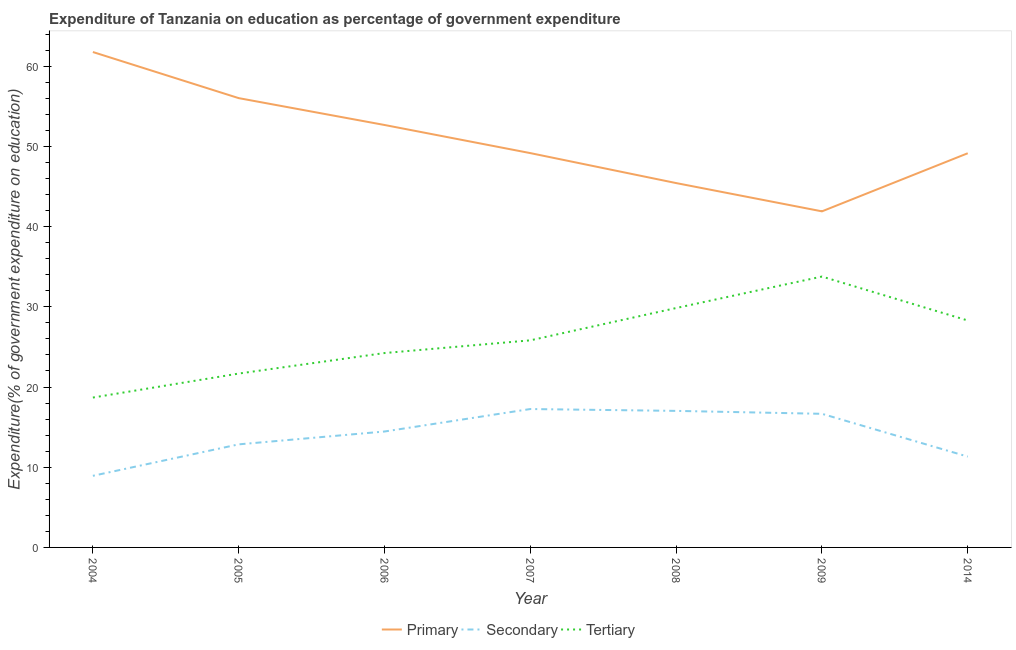How many different coloured lines are there?
Keep it short and to the point. 3. What is the expenditure on secondary education in 2004?
Offer a terse response. 8.93. Across all years, what is the maximum expenditure on secondary education?
Ensure brevity in your answer.  17.26. Across all years, what is the minimum expenditure on tertiary education?
Your response must be concise. 18.69. What is the total expenditure on tertiary education in the graph?
Offer a very short reply. 182.35. What is the difference between the expenditure on tertiary education in 2006 and that in 2007?
Your answer should be compact. -1.58. What is the difference between the expenditure on primary education in 2008 and the expenditure on secondary education in 2006?
Your answer should be compact. 30.98. What is the average expenditure on tertiary education per year?
Make the answer very short. 26.05. In the year 2006, what is the difference between the expenditure on primary education and expenditure on tertiary education?
Your answer should be very brief. 28.44. What is the ratio of the expenditure on primary education in 2006 to that in 2009?
Offer a very short reply. 1.26. Is the difference between the expenditure on secondary education in 2005 and 2007 greater than the difference between the expenditure on tertiary education in 2005 and 2007?
Your answer should be very brief. No. What is the difference between the highest and the second highest expenditure on secondary education?
Give a very brief answer. 0.23. What is the difference between the highest and the lowest expenditure on tertiary education?
Provide a short and direct response. 15.09. Does the expenditure on tertiary education monotonically increase over the years?
Your answer should be compact. No. How many years are there in the graph?
Make the answer very short. 7. Does the graph contain any zero values?
Make the answer very short. No. Where does the legend appear in the graph?
Keep it short and to the point. Bottom center. How many legend labels are there?
Provide a short and direct response. 3. What is the title of the graph?
Keep it short and to the point. Expenditure of Tanzania on education as percentage of government expenditure. What is the label or title of the Y-axis?
Keep it short and to the point. Expenditure(% of government expenditure on education). What is the Expenditure(% of government expenditure on education) of Primary in 2004?
Offer a very short reply. 61.77. What is the Expenditure(% of government expenditure on education) of Secondary in 2004?
Give a very brief answer. 8.93. What is the Expenditure(% of government expenditure on education) in Tertiary in 2004?
Offer a very short reply. 18.69. What is the Expenditure(% of government expenditure on education) of Primary in 2005?
Your answer should be very brief. 56.02. What is the Expenditure(% of government expenditure on education) in Secondary in 2005?
Your answer should be very brief. 12.85. What is the Expenditure(% of government expenditure on education) in Tertiary in 2005?
Offer a terse response. 21.68. What is the Expenditure(% of government expenditure on education) in Primary in 2006?
Your answer should be compact. 52.68. What is the Expenditure(% of government expenditure on education) of Secondary in 2006?
Provide a succinct answer. 14.45. What is the Expenditure(% of government expenditure on education) in Tertiary in 2006?
Your answer should be compact. 24.24. What is the Expenditure(% of government expenditure on education) in Primary in 2007?
Provide a succinct answer. 49.17. What is the Expenditure(% of government expenditure on education) of Secondary in 2007?
Your response must be concise. 17.26. What is the Expenditure(% of government expenditure on education) in Tertiary in 2007?
Make the answer very short. 25.82. What is the Expenditure(% of government expenditure on education) of Primary in 2008?
Make the answer very short. 45.43. What is the Expenditure(% of government expenditure on education) in Secondary in 2008?
Offer a very short reply. 17.03. What is the Expenditure(% of government expenditure on education) of Tertiary in 2008?
Keep it short and to the point. 29.85. What is the Expenditure(% of government expenditure on education) of Primary in 2009?
Provide a short and direct response. 41.91. What is the Expenditure(% of government expenditure on education) in Secondary in 2009?
Provide a short and direct response. 16.66. What is the Expenditure(% of government expenditure on education) in Tertiary in 2009?
Your answer should be very brief. 33.78. What is the Expenditure(% of government expenditure on education) in Primary in 2014?
Your answer should be compact. 49.15. What is the Expenditure(% of government expenditure on education) in Secondary in 2014?
Keep it short and to the point. 11.32. What is the Expenditure(% of government expenditure on education) of Tertiary in 2014?
Offer a very short reply. 28.3. Across all years, what is the maximum Expenditure(% of government expenditure on education) in Primary?
Provide a succinct answer. 61.77. Across all years, what is the maximum Expenditure(% of government expenditure on education) in Secondary?
Provide a short and direct response. 17.26. Across all years, what is the maximum Expenditure(% of government expenditure on education) of Tertiary?
Make the answer very short. 33.78. Across all years, what is the minimum Expenditure(% of government expenditure on education) of Primary?
Provide a succinct answer. 41.91. Across all years, what is the minimum Expenditure(% of government expenditure on education) in Secondary?
Your answer should be very brief. 8.93. Across all years, what is the minimum Expenditure(% of government expenditure on education) of Tertiary?
Offer a very short reply. 18.69. What is the total Expenditure(% of government expenditure on education) of Primary in the graph?
Offer a very short reply. 356.13. What is the total Expenditure(% of government expenditure on education) in Secondary in the graph?
Your answer should be very brief. 98.5. What is the total Expenditure(% of government expenditure on education) in Tertiary in the graph?
Offer a terse response. 182.35. What is the difference between the Expenditure(% of government expenditure on education) of Primary in 2004 and that in 2005?
Offer a very short reply. 5.75. What is the difference between the Expenditure(% of government expenditure on education) in Secondary in 2004 and that in 2005?
Your answer should be very brief. -3.92. What is the difference between the Expenditure(% of government expenditure on education) of Tertiary in 2004 and that in 2005?
Offer a terse response. -2.99. What is the difference between the Expenditure(% of government expenditure on education) of Primary in 2004 and that in 2006?
Provide a succinct answer. 9.1. What is the difference between the Expenditure(% of government expenditure on education) of Secondary in 2004 and that in 2006?
Give a very brief answer. -5.52. What is the difference between the Expenditure(% of government expenditure on education) of Tertiary in 2004 and that in 2006?
Keep it short and to the point. -5.55. What is the difference between the Expenditure(% of government expenditure on education) of Primary in 2004 and that in 2007?
Your answer should be very brief. 12.61. What is the difference between the Expenditure(% of government expenditure on education) in Secondary in 2004 and that in 2007?
Offer a very short reply. -8.33. What is the difference between the Expenditure(% of government expenditure on education) of Tertiary in 2004 and that in 2007?
Offer a very short reply. -7.13. What is the difference between the Expenditure(% of government expenditure on education) of Primary in 2004 and that in 2008?
Provide a succinct answer. 16.34. What is the difference between the Expenditure(% of government expenditure on education) of Secondary in 2004 and that in 2008?
Keep it short and to the point. -8.1. What is the difference between the Expenditure(% of government expenditure on education) in Tertiary in 2004 and that in 2008?
Provide a short and direct response. -11.16. What is the difference between the Expenditure(% of government expenditure on education) of Primary in 2004 and that in 2009?
Offer a terse response. 19.87. What is the difference between the Expenditure(% of government expenditure on education) in Secondary in 2004 and that in 2009?
Provide a short and direct response. -7.73. What is the difference between the Expenditure(% of government expenditure on education) of Tertiary in 2004 and that in 2009?
Your answer should be compact. -15.09. What is the difference between the Expenditure(% of government expenditure on education) of Primary in 2004 and that in 2014?
Your answer should be very brief. 12.62. What is the difference between the Expenditure(% of government expenditure on education) in Secondary in 2004 and that in 2014?
Keep it short and to the point. -2.39. What is the difference between the Expenditure(% of government expenditure on education) of Tertiary in 2004 and that in 2014?
Make the answer very short. -9.61. What is the difference between the Expenditure(% of government expenditure on education) in Primary in 2005 and that in 2006?
Your response must be concise. 3.35. What is the difference between the Expenditure(% of government expenditure on education) of Secondary in 2005 and that in 2006?
Your answer should be very brief. -1.6. What is the difference between the Expenditure(% of government expenditure on education) of Tertiary in 2005 and that in 2006?
Offer a terse response. -2.56. What is the difference between the Expenditure(% of government expenditure on education) in Primary in 2005 and that in 2007?
Ensure brevity in your answer.  6.85. What is the difference between the Expenditure(% of government expenditure on education) of Secondary in 2005 and that in 2007?
Offer a very short reply. -4.41. What is the difference between the Expenditure(% of government expenditure on education) of Tertiary in 2005 and that in 2007?
Give a very brief answer. -4.14. What is the difference between the Expenditure(% of government expenditure on education) in Primary in 2005 and that in 2008?
Your answer should be compact. 10.59. What is the difference between the Expenditure(% of government expenditure on education) in Secondary in 2005 and that in 2008?
Your answer should be compact. -4.17. What is the difference between the Expenditure(% of government expenditure on education) of Tertiary in 2005 and that in 2008?
Give a very brief answer. -8.17. What is the difference between the Expenditure(% of government expenditure on education) of Primary in 2005 and that in 2009?
Provide a succinct answer. 14.12. What is the difference between the Expenditure(% of government expenditure on education) of Secondary in 2005 and that in 2009?
Offer a very short reply. -3.81. What is the difference between the Expenditure(% of government expenditure on education) in Tertiary in 2005 and that in 2009?
Offer a terse response. -12.1. What is the difference between the Expenditure(% of government expenditure on education) in Primary in 2005 and that in 2014?
Make the answer very short. 6.87. What is the difference between the Expenditure(% of government expenditure on education) in Secondary in 2005 and that in 2014?
Offer a very short reply. 1.53. What is the difference between the Expenditure(% of government expenditure on education) of Tertiary in 2005 and that in 2014?
Your answer should be compact. -6.62. What is the difference between the Expenditure(% of government expenditure on education) in Primary in 2006 and that in 2007?
Keep it short and to the point. 3.51. What is the difference between the Expenditure(% of government expenditure on education) in Secondary in 2006 and that in 2007?
Offer a very short reply. -2.8. What is the difference between the Expenditure(% of government expenditure on education) of Tertiary in 2006 and that in 2007?
Your response must be concise. -1.58. What is the difference between the Expenditure(% of government expenditure on education) in Primary in 2006 and that in 2008?
Keep it short and to the point. 7.24. What is the difference between the Expenditure(% of government expenditure on education) of Secondary in 2006 and that in 2008?
Ensure brevity in your answer.  -2.57. What is the difference between the Expenditure(% of government expenditure on education) in Tertiary in 2006 and that in 2008?
Offer a terse response. -5.61. What is the difference between the Expenditure(% of government expenditure on education) of Primary in 2006 and that in 2009?
Make the answer very short. 10.77. What is the difference between the Expenditure(% of government expenditure on education) of Secondary in 2006 and that in 2009?
Your response must be concise. -2.21. What is the difference between the Expenditure(% of government expenditure on education) of Tertiary in 2006 and that in 2009?
Provide a succinct answer. -9.54. What is the difference between the Expenditure(% of government expenditure on education) of Primary in 2006 and that in 2014?
Your answer should be very brief. 3.53. What is the difference between the Expenditure(% of government expenditure on education) of Secondary in 2006 and that in 2014?
Provide a short and direct response. 3.13. What is the difference between the Expenditure(% of government expenditure on education) of Tertiary in 2006 and that in 2014?
Offer a very short reply. -4.06. What is the difference between the Expenditure(% of government expenditure on education) in Primary in 2007 and that in 2008?
Your answer should be compact. 3.74. What is the difference between the Expenditure(% of government expenditure on education) in Secondary in 2007 and that in 2008?
Ensure brevity in your answer.  0.23. What is the difference between the Expenditure(% of government expenditure on education) of Tertiary in 2007 and that in 2008?
Make the answer very short. -4.03. What is the difference between the Expenditure(% of government expenditure on education) of Primary in 2007 and that in 2009?
Your answer should be compact. 7.26. What is the difference between the Expenditure(% of government expenditure on education) of Secondary in 2007 and that in 2009?
Provide a short and direct response. 0.6. What is the difference between the Expenditure(% of government expenditure on education) in Tertiary in 2007 and that in 2009?
Provide a succinct answer. -7.95. What is the difference between the Expenditure(% of government expenditure on education) of Primary in 2007 and that in 2014?
Offer a terse response. 0.02. What is the difference between the Expenditure(% of government expenditure on education) in Secondary in 2007 and that in 2014?
Provide a succinct answer. 5.93. What is the difference between the Expenditure(% of government expenditure on education) of Tertiary in 2007 and that in 2014?
Provide a short and direct response. -2.47. What is the difference between the Expenditure(% of government expenditure on education) of Primary in 2008 and that in 2009?
Keep it short and to the point. 3.53. What is the difference between the Expenditure(% of government expenditure on education) in Secondary in 2008 and that in 2009?
Provide a succinct answer. 0.37. What is the difference between the Expenditure(% of government expenditure on education) in Tertiary in 2008 and that in 2009?
Provide a succinct answer. -3.93. What is the difference between the Expenditure(% of government expenditure on education) of Primary in 2008 and that in 2014?
Ensure brevity in your answer.  -3.72. What is the difference between the Expenditure(% of government expenditure on education) in Secondary in 2008 and that in 2014?
Provide a succinct answer. 5.7. What is the difference between the Expenditure(% of government expenditure on education) in Tertiary in 2008 and that in 2014?
Provide a short and direct response. 1.55. What is the difference between the Expenditure(% of government expenditure on education) of Primary in 2009 and that in 2014?
Keep it short and to the point. -7.24. What is the difference between the Expenditure(% of government expenditure on education) of Secondary in 2009 and that in 2014?
Offer a very short reply. 5.34. What is the difference between the Expenditure(% of government expenditure on education) in Tertiary in 2009 and that in 2014?
Your response must be concise. 5.48. What is the difference between the Expenditure(% of government expenditure on education) in Primary in 2004 and the Expenditure(% of government expenditure on education) in Secondary in 2005?
Give a very brief answer. 48.92. What is the difference between the Expenditure(% of government expenditure on education) of Primary in 2004 and the Expenditure(% of government expenditure on education) of Tertiary in 2005?
Your answer should be compact. 40.09. What is the difference between the Expenditure(% of government expenditure on education) of Secondary in 2004 and the Expenditure(% of government expenditure on education) of Tertiary in 2005?
Provide a succinct answer. -12.75. What is the difference between the Expenditure(% of government expenditure on education) of Primary in 2004 and the Expenditure(% of government expenditure on education) of Secondary in 2006?
Make the answer very short. 47.32. What is the difference between the Expenditure(% of government expenditure on education) in Primary in 2004 and the Expenditure(% of government expenditure on education) in Tertiary in 2006?
Ensure brevity in your answer.  37.54. What is the difference between the Expenditure(% of government expenditure on education) of Secondary in 2004 and the Expenditure(% of government expenditure on education) of Tertiary in 2006?
Your answer should be compact. -15.31. What is the difference between the Expenditure(% of government expenditure on education) in Primary in 2004 and the Expenditure(% of government expenditure on education) in Secondary in 2007?
Offer a very short reply. 44.52. What is the difference between the Expenditure(% of government expenditure on education) of Primary in 2004 and the Expenditure(% of government expenditure on education) of Tertiary in 2007?
Offer a terse response. 35.95. What is the difference between the Expenditure(% of government expenditure on education) in Secondary in 2004 and the Expenditure(% of government expenditure on education) in Tertiary in 2007?
Make the answer very short. -16.89. What is the difference between the Expenditure(% of government expenditure on education) of Primary in 2004 and the Expenditure(% of government expenditure on education) of Secondary in 2008?
Your answer should be very brief. 44.75. What is the difference between the Expenditure(% of government expenditure on education) of Primary in 2004 and the Expenditure(% of government expenditure on education) of Tertiary in 2008?
Make the answer very short. 31.92. What is the difference between the Expenditure(% of government expenditure on education) in Secondary in 2004 and the Expenditure(% of government expenditure on education) in Tertiary in 2008?
Ensure brevity in your answer.  -20.92. What is the difference between the Expenditure(% of government expenditure on education) of Primary in 2004 and the Expenditure(% of government expenditure on education) of Secondary in 2009?
Your answer should be compact. 45.11. What is the difference between the Expenditure(% of government expenditure on education) in Primary in 2004 and the Expenditure(% of government expenditure on education) in Tertiary in 2009?
Provide a short and direct response. 28. What is the difference between the Expenditure(% of government expenditure on education) of Secondary in 2004 and the Expenditure(% of government expenditure on education) of Tertiary in 2009?
Ensure brevity in your answer.  -24.85. What is the difference between the Expenditure(% of government expenditure on education) of Primary in 2004 and the Expenditure(% of government expenditure on education) of Secondary in 2014?
Offer a terse response. 50.45. What is the difference between the Expenditure(% of government expenditure on education) in Primary in 2004 and the Expenditure(% of government expenditure on education) in Tertiary in 2014?
Your response must be concise. 33.48. What is the difference between the Expenditure(% of government expenditure on education) of Secondary in 2004 and the Expenditure(% of government expenditure on education) of Tertiary in 2014?
Offer a very short reply. -19.37. What is the difference between the Expenditure(% of government expenditure on education) in Primary in 2005 and the Expenditure(% of government expenditure on education) in Secondary in 2006?
Provide a succinct answer. 41.57. What is the difference between the Expenditure(% of government expenditure on education) in Primary in 2005 and the Expenditure(% of government expenditure on education) in Tertiary in 2006?
Offer a terse response. 31.79. What is the difference between the Expenditure(% of government expenditure on education) of Secondary in 2005 and the Expenditure(% of government expenditure on education) of Tertiary in 2006?
Give a very brief answer. -11.39. What is the difference between the Expenditure(% of government expenditure on education) of Primary in 2005 and the Expenditure(% of government expenditure on education) of Secondary in 2007?
Provide a succinct answer. 38.77. What is the difference between the Expenditure(% of government expenditure on education) of Primary in 2005 and the Expenditure(% of government expenditure on education) of Tertiary in 2007?
Provide a succinct answer. 30.2. What is the difference between the Expenditure(% of government expenditure on education) of Secondary in 2005 and the Expenditure(% of government expenditure on education) of Tertiary in 2007?
Your answer should be compact. -12.97. What is the difference between the Expenditure(% of government expenditure on education) of Primary in 2005 and the Expenditure(% of government expenditure on education) of Secondary in 2008?
Make the answer very short. 39. What is the difference between the Expenditure(% of government expenditure on education) in Primary in 2005 and the Expenditure(% of government expenditure on education) in Tertiary in 2008?
Your response must be concise. 26.17. What is the difference between the Expenditure(% of government expenditure on education) of Secondary in 2005 and the Expenditure(% of government expenditure on education) of Tertiary in 2008?
Your answer should be compact. -17. What is the difference between the Expenditure(% of government expenditure on education) in Primary in 2005 and the Expenditure(% of government expenditure on education) in Secondary in 2009?
Provide a short and direct response. 39.36. What is the difference between the Expenditure(% of government expenditure on education) of Primary in 2005 and the Expenditure(% of government expenditure on education) of Tertiary in 2009?
Your answer should be very brief. 22.25. What is the difference between the Expenditure(% of government expenditure on education) in Secondary in 2005 and the Expenditure(% of government expenditure on education) in Tertiary in 2009?
Give a very brief answer. -20.92. What is the difference between the Expenditure(% of government expenditure on education) in Primary in 2005 and the Expenditure(% of government expenditure on education) in Secondary in 2014?
Your answer should be very brief. 44.7. What is the difference between the Expenditure(% of government expenditure on education) in Primary in 2005 and the Expenditure(% of government expenditure on education) in Tertiary in 2014?
Your response must be concise. 27.73. What is the difference between the Expenditure(% of government expenditure on education) in Secondary in 2005 and the Expenditure(% of government expenditure on education) in Tertiary in 2014?
Make the answer very short. -15.45. What is the difference between the Expenditure(% of government expenditure on education) in Primary in 2006 and the Expenditure(% of government expenditure on education) in Secondary in 2007?
Your response must be concise. 35.42. What is the difference between the Expenditure(% of government expenditure on education) of Primary in 2006 and the Expenditure(% of government expenditure on education) of Tertiary in 2007?
Your answer should be very brief. 26.85. What is the difference between the Expenditure(% of government expenditure on education) of Secondary in 2006 and the Expenditure(% of government expenditure on education) of Tertiary in 2007?
Offer a terse response. -11.37. What is the difference between the Expenditure(% of government expenditure on education) of Primary in 2006 and the Expenditure(% of government expenditure on education) of Secondary in 2008?
Make the answer very short. 35.65. What is the difference between the Expenditure(% of government expenditure on education) in Primary in 2006 and the Expenditure(% of government expenditure on education) in Tertiary in 2008?
Provide a short and direct response. 22.83. What is the difference between the Expenditure(% of government expenditure on education) of Secondary in 2006 and the Expenditure(% of government expenditure on education) of Tertiary in 2008?
Provide a succinct answer. -15.4. What is the difference between the Expenditure(% of government expenditure on education) of Primary in 2006 and the Expenditure(% of government expenditure on education) of Secondary in 2009?
Ensure brevity in your answer.  36.02. What is the difference between the Expenditure(% of government expenditure on education) of Primary in 2006 and the Expenditure(% of government expenditure on education) of Tertiary in 2009?
Ensure brevity in your answer.  18.9. What is the difference between the Expenditure(% of government expenditure on education) in Secondary in 2006 and the Expenditure(% of government expenditure on education) in Tertiary in 2009?
Your response must be concise. -19.32. What is the difference between the Expenditure(% of government expenditure on education) in Primary in 2006 and the Expenditure(% of government expenditure on education) in Secondary in 2014?
Offer a terse response. 41.35. What is the difference between the Expenditure(% of government expenditure on education) in Primary in 2006 and the Expenditure(% of government expenditure on education) in Tertiary in 2014?
Provide a succinct answer. 24.38. What is the difference between the Expenditure(% of government expenditure on education) in Secondary in 2006 and the Expenditure(% of government expenditure on education) in Tertiary in 2014?
Ensure brevity in your answer.  -13.84. What is the difference between the Expenditure(% of government expenditure on education) of Primary in 2007 and the Expenditure(% of government expenditure on education) of Secondary in 2008?
Offer a very short reply. 32.14. What is the difference between the Expenditure(% of government expenditure on education) of Primary in 2007 and the Expenditure(% of government expenditure on education) of Tertiary in 2008?
Make the answer very short. 19.32. What is the difference between the Expenditure(% of government expenditure on education) of Secondary in 2007 and the Expenditure(% of government expenditure on education) of Tertiary in 2008?
Keep it short and to the point. -12.59. What is the difference between the Expenditure(% of government expenditure on education) in Primary in 2007 and the Expenditure(% of government expenditure on education) in Secondary in 2009?
Your answer should be very brief. 32.51. What is the difference between the Expenditure(% of government expenditure on education) in Primary in 2007 and the Expenditure(% of government expenditure on education) in Tertiary in 2009?
Provide a short and direct response. 15.39. What is the difference between the Expenditure(% of government expenditure on education) of Secondary in 2007 and the Expenditure(% of government expenditure on education) of Tertiary in 2009?
Offer a terse response. -16.52. What is the difference between the Expenditure(% of government expenditure on education) in Primary in 2007 and the Expenditure(% of government expenditure on education) in Secondary in 2014?
Offer a terse response. 37.84. What is the difference between the Expenditure(% of government expenditure on education) in Primary in 2007 and the Expenditure(% of government expenditure on education) in Tertiary in 2014?
Ensure brevity in your answer.  20.87. What is the difference between the Expenditure(% of government expenditure on education) in Secondary in 2007 and the Expenditure(% of government expenditure on education) in Tertiary in 2014?
Provide a short and direct response. -11.04. What is the difference between the Expenditure(% of government expenditure on education) in Primary in 2008 and the Expenditure(% of government expenditure on education) in Secondary in 2009?
Your answer should be compact. 28.77. What is the difference between the Expenditure(% of government expenditure on education) in Primary in 2008 and the Expenditure(% of government expenditure on education) in Tertiary in 2009?
Offer a terse response. 11.66. What is the difference between the Expenditure(% of government expenditure on education) in Secondary in 2008 and the Expenditure(% of government expenditure on education) in Tertiary in 2009?
Provide a succinct answer. -16.75. What is the difference between the Expenditure(% of government expenditure on education) of Primary in 2008 and the Expenditure(% of government expenditure on education) of Secondary in 2014?
Give a very brief answer. 34.11. What is the difference between the Expenditure(% of government expenditure on education) in Primary in 2008 and the Expenditure(% of government expenditure on education) in Tertiary in 2014?
Keep it short and to the point. 17.14. What is the difference between the Expenditure(% of government expenditure on education) in Secondary in 2008 and the Expenditure(% of government expenditure on education) in Tertiary in 2014?
Provide a short and direct response. -11.27. What is the difference between the Expenditure(% of government expenditure on education) of Primary in 2009 and the Expenditure(% of government expenditure on education) of Secondary in 2014?
Your answer should be very brief. 30.58. What is the difference between the Expenditure(% of government expenditure on education) in Primary in 2009 and the Expenditure(% of government expenditure on education) in Tertiary in 2014?
Make the answer very short. 13.61. What is the difference between the Expenditure(% of government expenditure on education) in Secondary in 2009 and the Expenditure(% of government expenditure on education) in Tertiary in 2014?
Provide a short and direct response. -11.64. What is the average Expenditure(% of government expenditure on education) of Primary per year?
Your answer should be very brief. 50.88. What is the average Expenditure(% of government expenditure on education) of Secondary per year?
Keep it short and to the point. 14.07. What is the average Expenditure(% of government expenditure on education) in Tertiary per year?
Provide a succinct answer. 26.05. In the year 2004, what is the difference between the Expenditure(% of government expenditure on education) of Primary and Expenditure(% of government expenditure on education) of Secondary?
Offer a terse response. 52.84. In the year 2004, what is the difference between the Expenditure(% of government expenditure on education) in Primary and Expenditure(% of government expenditure on education) in Tertiary?
Keep it short and to the point. 43.09. In the year 2004, what is the difference between the Expenditure(% of government expenditure on education) in Secondary and Expenditure(% of government expenditure on education) in Tertiary?
Your answer should be very brief. -9.76. In the year 2005, what is the difference between the Expenditure(% of government expenditure on education) in Primary and Expenditure(% of government expenditure on education) in Secondary?
Provide a succinct answer. 43.17. In the year 2005, what is the difference between the Expenditure(% of government expenditure on education) in Primary and Expenditure(% of government expenditure on education) in Tertiary?
Provide a succinct answer. 34.34. In the year 2005, what is the difference between the Expenditure(% of government expenditure on education) of Secondary and Expenditure(% of government expenditure on education) of Tertiary?
Make the answer very short. -8.83. In the year 2006, what is the difference between the Expenditure(% of government expenditure on education) in Primary and Expenditure(% of government expenditure on education) in Secondary?
Your answer should be very brief. 38.22. In the year 2006, what is the difference between the Expenditure(% of government expenditure on education) of Primary and Expenditure(% of government expenditure on education) of Tertiary?
Ensure brevity in your answer.  28.44. In the year 2006, what is the difference between the Expenditure(% of government expenditure on education) in Secondary and Expenditure(% of government expenditure on education) in Tertiary?
Your response must be concise. -9.78. In the year 2007, what is the difference between the Expenditure(% of government expenditure on education) in Primary and Expenditure(% of government expenditure on education) in Secondary?
Offer a very short reply. 31.91. In the year 2007, what is the difference between the Expenditure(% of government expenditure on education) in Primary and Expenditure(% of government expenditure on education) in Tertiary?
Your answer should be compact. 23.35. In the year 2007, what is the difference between the Expenditure(% of government expenditure on education) of Secondary and Expenditure(% of government expenditure on education) of Tertiary?
Provide a short and direct response. -8.57. In the year 2008, what is the difference between the Expenditure(% of government expenditure on education) of Primary and Expenditure(% of government expenditure on education) of Secondary?
Make the answer very short. 28.41. In the year 2008, what is the difference between the Expenditure(% of government expenditure on education) in Primary and Expenditure(% of government expenditure on education) in Tertiary?
Keep it short and to the point. 15.58. In the year 2008, what is the difference between the Expenditure(% of government expenditure on education) of Secondary and Expenditure(% of government expenditure on education) of Tertiary?
Your answer should be compact. -12.82. In the year 2009, what is the difference between the Expenditure(% of government expenditure on education) of Primary and Expenditure(% of government expenditure on education) of Secondary?
Provide a short and direct response. 25.25. In the year 2009, what is the difference between the Expenditure(% of government expenditure on education) of Primary and Expenditure(% of government expenditure on education) of Tertiary?
Give a very brief answer. 8.13. In the year 2009, what is the difference between the Expenditure(% of government expenditure on education) in Secondary and Expenditure(% of government expenditure on education) in Tertiary?
Offer a terse response. -17.11. In the year 2014, what is the difference between the Expenditure(% of government expenditure on education) in Primary and Expenditure(% of government expenditure on education) in Secondary?
Make the answer very short. 37.83. In the year 2014, what is the difference between the Expenditure(% of government expenditure on education) of Primary and Expenditure(% of government expenditure on education) of Tertiary?
Keep it short and to the point. 20.85. In the year 2014, what is the difference between the Expenditure(% of government expenditure on education) in Secondary and Expenditure(% of government expenditure on education) in Tertiary?
Your answer should be compact. -16.97. What is the ratio of the Expenditure(% of government expenditure on education) in Primary in 2004 to that in 2005?
Offer a terse response. 1.1. What is the ratio of the Expenditure(% of government expenditure on education) in Secondary in 2004 to that in 2005?
Your response must be concise. 0.69. What is the ratio of the Expenditure(% of government expenditure on education) of Tertiary in 2004 to that in 2005?
Keep it short and to the point. 0.86. What is the ratio of the Expenditure(% of government expenditure on education) of Primary in 2004 to that in 2006?
Your response must be concise. 1.17. What is the ratio of the Expenditure(% of government expenditure on education) in Secondary in 2004 to that in 2006?
Offer a terse response. 0.62. What is the ratio of the Expenditure(% of government expenditure on education) of Tertiary in 2004 to that in 2006?
Offer a very short reply. 0.77. What is the ratio of the Expenditure(% of government expenditure on education) of Primary in 2004 to that in 2007?
Your answer should be compact. 1.26. What is the ratio of the Expenditure(% of government expenditure on education) of Secondary in 2004 to that in 2007?
Your answer should be compact. 0.52. What is the ratio of the Expenditure(% of government expenditure on education) in Tertiary in 2004 to that in 2007?
Offer a terse response. 0.72. What is the ratio of the Expenditure(% of government expenditure on education) of Primary in 2004 to that in 2008?
Keep it short and to the point. 1.36. What is the ratio of the Expenditure(% of government expenditure on education) of Secondary in 2004 to that in 2008?
Provide a short and direct response. 0.52. What is the ratio of the Expenditure(% of government expenditure on education) in Tertiary in 2004 to that in 2008?
Your response must be concise. 0.63. What is the ratio of the Expenditure(% of government expenditure on education) in Primary in 2004 to that in 2009?
Give a very brief answer. 1.47. What is the ratio of the Expenditure(% of government expenditure on education) in Secondary in 2004 to that in 2009?
Offer a terse response. 0.54. What is the ratio of the Expenditure(% of government expenditure on education) of Tertiary in 2004 to that in 2009?
Your response must be concise. 0.55. What is the ratio of the Expenditure(% of government expenditure on education) in Primary in 2004 to that in 2014?
Make the answer very short. 1.26. What is the ratio of the Expenditure(% of government expenditure on education) of Secondary in 2004 to that in 2014?
Make the answer very short. 0.79. What is the ratio of the Expenditure(% of government expenditure on education) in Tertiary in 2004 to that in 2014?
Your answer should be compact. 0.66. What is the ratio of the Expenditure(% of government expenditure on education) of Primary in 2005 to that in 2006?
Offer a very short reply. 1.06. What is the ratio of the Expenditure(% of government expenditure on education) of Secondary in 2005 to that in 2006?
Your answer should be compact. 0.89. What is the ratio of the Expenditure(% of government expenditure on education) of Tertiary in 2005 to that in 2006?
Your answer should be very brief. 0.89. What is the ratio of the Expenditure(% of government expenditure on education) in Primary in 2005 to that in 2007?
Your answer should be compact. 1.14. What is the ratio of the Expenditure(% of government expenditure on education) of Secondary in 2005 to that in 2007?
Keep it short and to the point. 0.74. What is the ratio of the Expenditure(% of government expenditure on education) in Tertiary in 2005 to that in 2007?
Make the answer very short. 0.84. What is the ratio of the Expenditure(% of government expenditure on education) of Primary in 2005 to that in 2008?
Offer a terse response. 1.23. What is the ratio of the Expenditure(% of government expenditure on education) of Secondary in 2005 to that in 2008?
Give a very brief answer. 0.75. What is the ratio of the Expenditure(% of government expenditure on education) of Tertiary in 2005 to that in 2008?
Your answer should be very brief. 0.73. What is the ratio of the Expenditure(% of government expenditure on education) in Primary in 2005 to that in 2009?
Offer a terse response. 1.34. What is the ratio of the Expenditure(% of government expenditure on education) of Secondary in 2005 to that in 2009?
Provide a short and direct response. 0.77. What is the ratio of the Expenditure(% of government expenditure on education) in Tertiary in 2005 to that in 2009?
Provide a succinct answer. 0.64. What is the ratio of the Expenditure(% of government expenditure on education) of Primary in 2005 to that in 2014?
Provide a succinct answer. 1.14. What is the ratio of the Expenditure(% of government expenditure on education) of Secondary in 2005 to that in 2014?
Your answer should be compact. 1.13. What is the ratio of the Expenditure(% of government expenditure on education) in Tertiary in 2005 to that in 2014?
Keep it short and to the point. 0.77. What is the ratio of the Expenditure(% of government expenditure on education) of Primary in 2006 to that in 2007?
Your response must be concise. 1.07. What is the ratio of the Expenditure(% of government expenditure on education) of Secondary in 2006 to that in 2007?
Make the answer very short. 0.84. What is the ratio of the Expenditure(% of government expenditure on education) in Tertiary in 2006 to that in 2007?
Provide a short and direct response. 0.94. What is the ratio of the Expenditure(% of government expenditure on education) of Primary in 2006 to that in 2008?
Provide a succinct answer. 1.16. What is the ratio of the Expenditure(% of government expenditure on education) of Secondary in 2006 to that in 2008?
Your response must be concise. 0.85. What is the ratio of the Expenditure(% of government expenditure on education) of Tertiary in 2006 to that in 2008?
Give a very brief answer. 0.81. What is the ratio of the Expenditure(% of government expenditure on education) of Primary in 2006 to that in 2009?
Your answer should be very brief. 1.26. What is the ratio of the Expenditure(% of government expenditure on education) in Secondary in 2006 to that in 2009?
Provide a succinct answer. 0.87. What is the ratio of the Expenditure(% of government expenditure on education) of Tertiary in 2006 to that in 2009?
Your answer should be compact. 0.72. What is the ratio of the Expenditure(% of government expenditure on education) of Primary in 2006 to that in 2014?
Provide a succinct answer. 1.07. What is the ratio of the Expenditure(% of government expenditure on education) of Secondary in 2006 to that in 2014?
Ensure brevity in your answer.  1.28. What is the ratio of the Expenditure(% of government expenditure on education) of Tertiary in 2006 to that in 2014?
Keep it short and to the point. 0.86. What is the ratio of the Expenditure(% of government expenditure on education) in Primary in 2007 to that in 2008?
Your response must be concise. 1.08. What is the ratio of the Expenditure(% of government expenditure on education) of Secondary in 2007 to that in 2008?
Offer a terse response. 1.01. What is the ratio of the Expenditure(% of government expenditure on education) in Tertiary in 2007 to that in 2008?
Provide a short and direct response. 0.87. What is the ratio of the Expenditure(% of government expenditure on education) in Primary in 2007 to that in 2009?
Make the answer very short. 1.17. What is the ratio of the Expenditure(% of government expenditure on education) of Secondary in 2007 to that in 2009?
Your answer should be very brief. 1.04. What is the ratio of the Expenditure(% of government expenditure on education) of Tertiary in 2007 to that in 2009?
Offer a very short reply. 0.76. What is the ratio of the Expenditure(% of government expenditure on education) of Primary in 2007 to that in 2014?
Your answer should be compact. 1. What is the ratio of the Expenditure(% of government expenditure on education) in Secondary in 2007 to that in 2014?
Your answer should be compact. 1.52. What is the ratio of the Expenditure(% of government expenditure on education) of Tertiary in 2007 to that in 2014?
Make the answer very short. 0.91. What is the ratio of the Expenditure(% of government expenditure on education) in Primary in 2008 to that in 2009?
Provide a short and direct response. 1.08. What is the ratio of the Expenditure(% of government expenditure on education) of Secondary in 2008 to that in 2009?
Provide a succinct answer. 1.02. What is the ratio of the Expenditure(% of government expenditure on education) in Tertiary in 2008 to that in 2009?
Keep it short and to the point. 0.88. What is the ratio of the Expenditure(% of government expenditure on education) of Primary in 2008 to that in 2014?
Provide a short and direct response. 0.92. What is the ratio of the Expenditure(% of government expenditure on education) in Secondary in 2008 to that in 2014?
Your response must be concise. 1.5. What is the ratio of the Expenditure(% of government expenditure on education) of Tertiary in 2008 to that in 2014?
Your answer should be very brief. 1.05. What is the ratio of the Expenditure(% of government expenditure on education) in Primary in 2009 to that in 2014?
Offer a very short reply. 0.85. What is the ratio of the Expenditure(% of government expenditure on education) in Secondary in 2009 to that in 2014?
Your answer should be very brief. 1.47. What is the ratio of the Expenditure(% of government expenditure on education) in Tertiary in 2009 to that in 2014?
Offer a very short reply. 1.19. What is the difference between the highest and the second highest Expenditure(% of government expenditure on education) of Primary?
Offer a terse response. 5.75. What is the difference between the highest and the second highest Expenditure(% of government expenditure on education) in Secondary?
Keep it short and to the point. 0.23. What is the difference between the highest and the second highest Expenditure(% of government expenditure on education) in Tertiary?
Keep it short and to the point. 3.93. What is the difference between the highest and the lowest Expenditure(% of government expenditure on education) of Primary?
Your answer should be compact. 19.87. What is the difference between the highest and the lowest Expenditure(% of government expenditure on education) of Secondary?
Make the answer very short. 8.33. What is the difference between the highest and the lowest Expenditure(% of government expenditure on education) in Tertiary?
Provide a short and direct response. 15.09. 